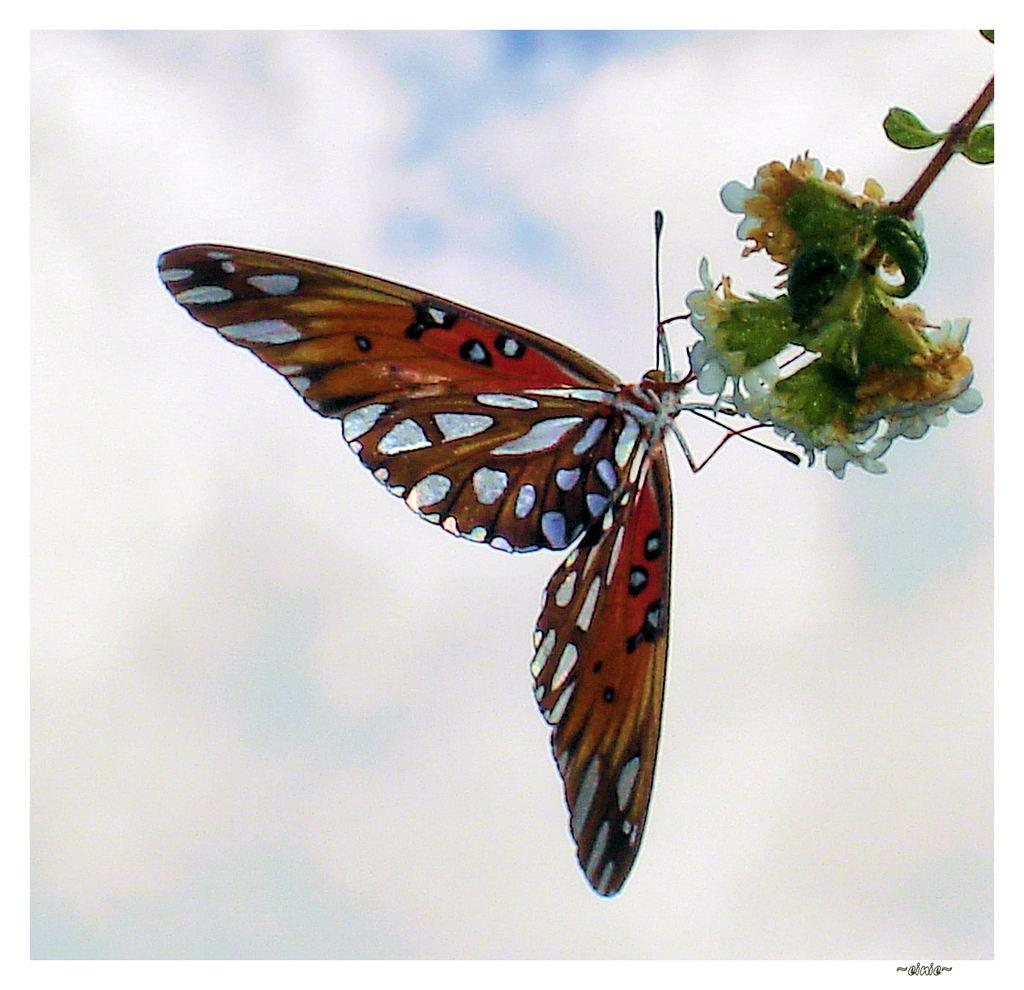What is the main subject of the image? There is a butterfly in the image. What is the butterfly doing in the image? The butterfly is eating a white flower. What can be seen in the background of the image? The sky is visible in the image. Are there any additional features in the sky? Yes, white clouds are present in the sky. 